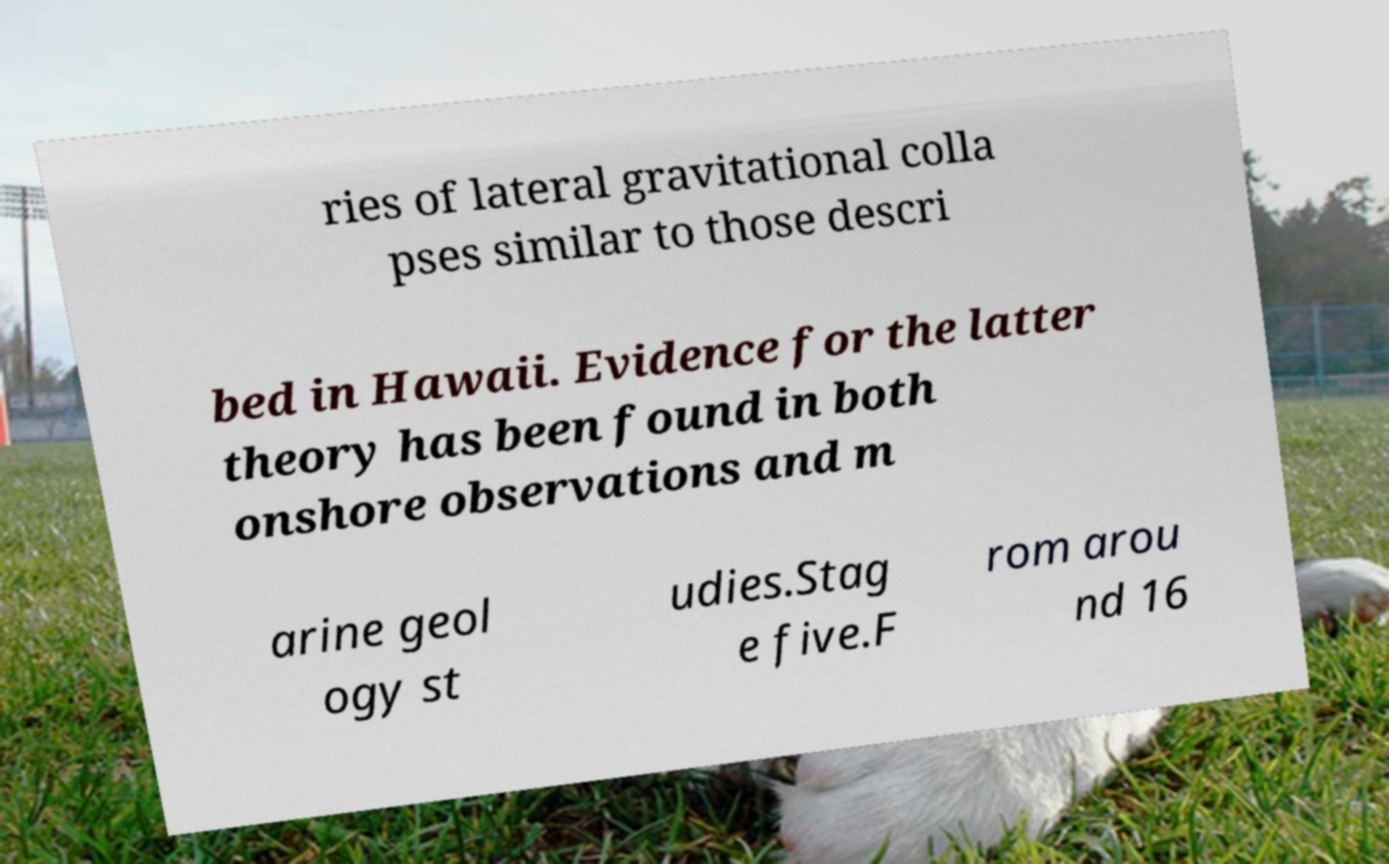Can you read and provide the text displayed in the image?This photo seems to have some interesting text. Can you extract and type it out for me? ries of lateral gravitational colla pses similar to those descri bed in Hawaii. Evidence for the latter theory has been found in both onshore observations and m arine geol ogy st udies.Stag e five.F rom arou nd 16 